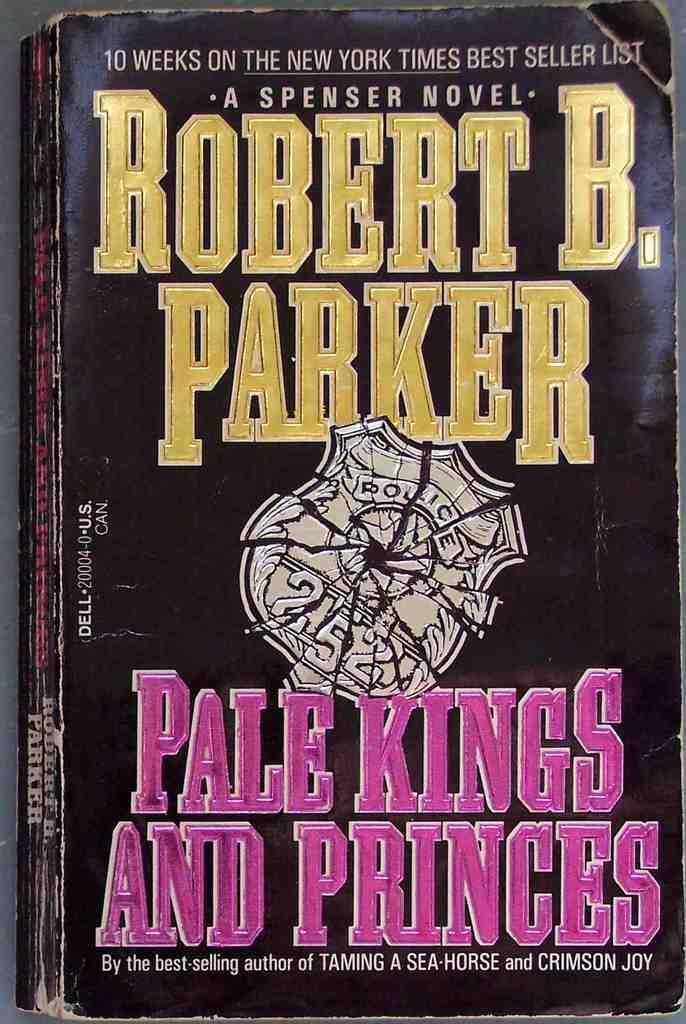Provide a one-sentence caption for the provided image. the novel "pale kings and the princes" by Robert B. Parker. 